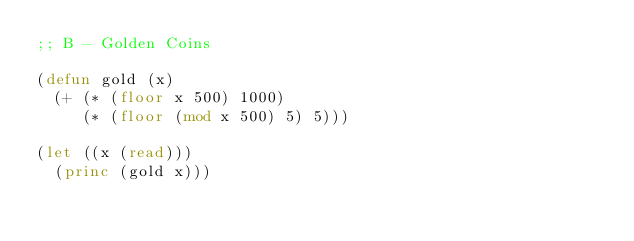<code> <loc_0><loc_0><loc_500><loc_500><_Lisp_>;; B - Golden Coins

(defun gold (x)
  (+ (* (floor x 500) 1000)
     (* (floor (mod x 500) 5) 5)))

(let ((x (read)))
  (princ (gold x)))
</code> 